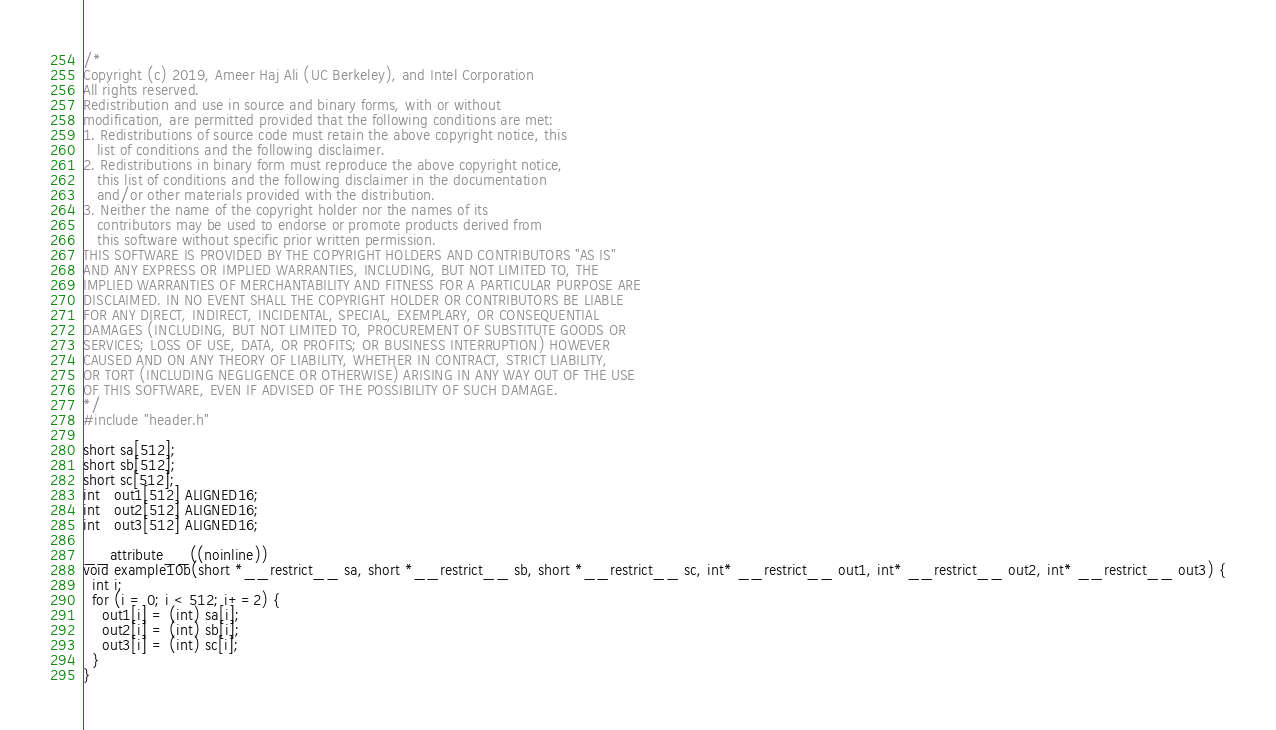<code> <loc_0><loc_0><loc_500><loc_500><_C_>/*
Copyright (c) 2019, Ameer Haj Ali (UC Berkeley), and Intel Corporation
All rights reserved.
Redistribution and use in source and binary forms, with or without
modification, are permitted provided that the following conditions are met:
1. Redistributions of source code must retain the above copyright notice, this
   list of conditions and the following disclaimer.
2. Redistributions in binary form must reproduce the above copyright notice,
   this list of conditions and the following disclaimer in the documentation
   and/or other materials provided with the distribution.
3. Neither the name of the copyright holder nor the names of its
   contributors may be used to endorse or promote products derived from
   this software without specific prior written permission.
THIS SOFTWARE IS PROVIDED BY THE COPYRIGHT HOLDERS AND CONTRIBUTORS "AS IS"
AND ANY EXPRESS OR IMPLIED WARRANTIES, INCLUDING, BUT NOT LIMITED TO, THE
IMPLIED WARRANTIES OF MERCHANTABILITY AND FITNESS FOR A PARTICULAR PURPOSE ARE
DISCLAIMED. IN NO EVENT SHALL THE COPYRIGHT HOLDER OR CONTRIBUTORS BE LIABLE
FOR ANY DIRECT, INDIRECT, INCIDENTAL, SPECIAL, EXEMPLARY, OR CONSEQUENTIAL
DAMAGES (INCLUDING, BUT NOT LIMITED TO, PROCUREMENT OF SUBSTITUTE GOODS OR
SERVICES; LOSS OF USE, DATA, OR PROFITS; OR BUSINESS INTERRUPTION) HOWEVER
CAUSED AND ON ANY THEORY OF LIABILITY, WHETHER IN CONTRACT, STRICT LIABILITY,
OR TORT (INCLUDING NEGLIGENCE OR OTHERWISE) ARISING IN ANY WAY OUT OF THE USE
OF THIS SOFTWARE, EVEN IF ADVISED OF THE POSSIBILITY OF SUCH DAMAGE.
*/
#include "header.h"

short sa[512];
short sb[512];
short sc[512];
int   out1[512] ALIGNED16;
int   out2[512] ALIGNED16;
int   out3[512] ALIGNED16;

__attribute__((noinline))
void example10b(short *__restrict__ sa, short *__restrict__ sb, short *__restrict__ sc, int* __restrict__ out1, int* __restrict__ out2, int* __restrict__ out3) {
  int i;
  for (i = 0; i < 512; i+=2) {
    out1[i] = (int) sa[i];
    out2[i] = (int) sb[i];
    out3[i] = (int) sc[i];
  }
}</code> 